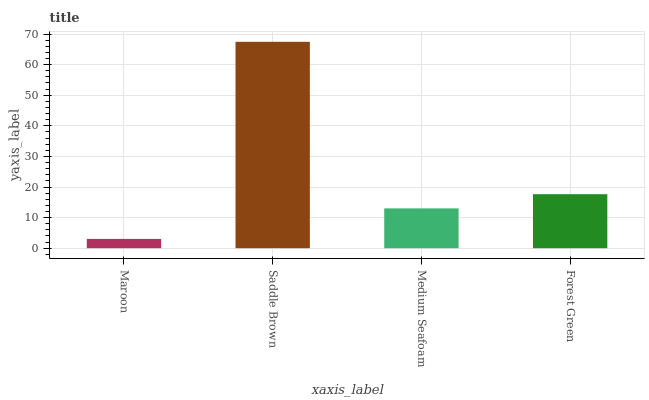Is Maroon the minimum?
Answer yes or no. Yes. Is Saddle Brown the maximum?
Answer yes or no. Yes. Is Medium Seafoam the minimum?
Answer yes or no. No. Is Medium Seafoam the maximum?
Answer yes or no. No. Is Saddle Brown greater than Medium Seafoam?
Answer yes or no. Yes. Is Medium Seafoam less than Saddle Brown?
Answer yes or no. Yes. Is Medium Seafoam greater than Saddle Brown?
Answer yes or no. No. Is Saddle Brown less than Medium Seafoam?
Answer yes or no. No. Is Forest Green the high median?
Answer yes or no. Yes. Is Medium Seafoam the low median?
Answer yes or no. Yes. Is Medium Seafoam the high median?
Answer yes or no. No. Is Saddle Brown the low median?
Answer yes or no. No. 